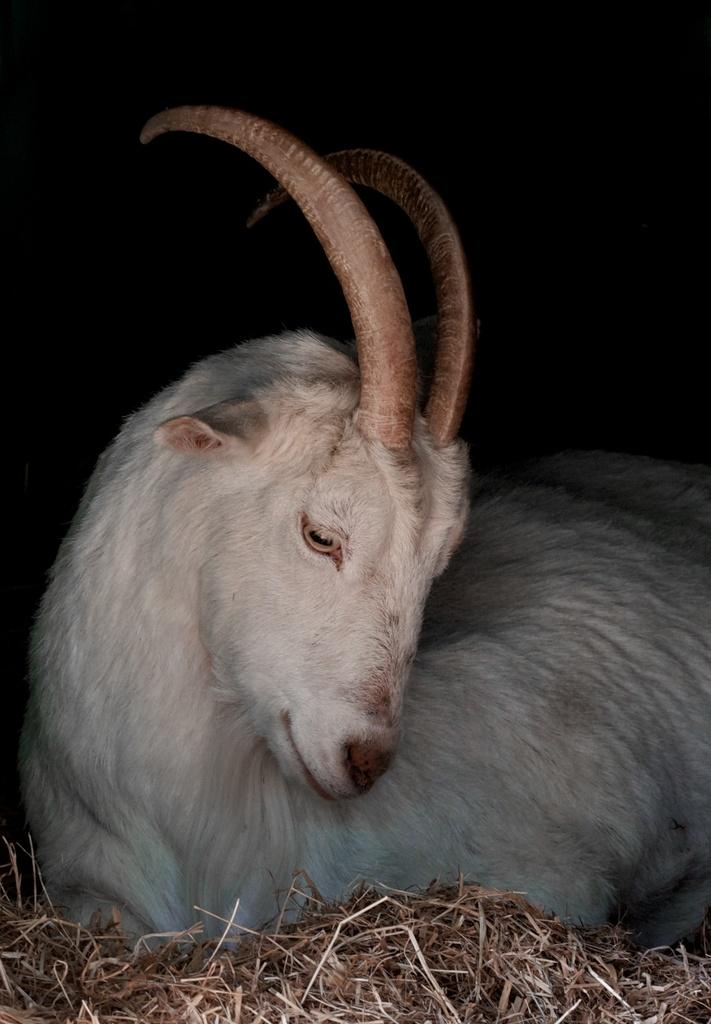What animal is present in the image? There is a goat in the image. What physical feature does the goat have? The goat has horns. What is the goat sitting on in the image? The goat is sitting on the grass. What is the color of the background in the image? The background of the image is black. What type of shirt is the goat wearing in the image? Goats do not wear shirts, so there is no shirt present in the image. What game is the goat playing in the image? There is no game being played in the image; it features a goat sitting on the grass. 